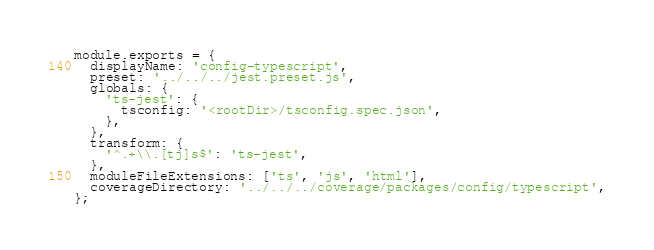<code> <loc_0><loc_0><loc_500><loc_500><_JavaScript_>module.exports = {
  displayName: 'config-typescript',
  preset: '../../../jest.preset.js',
  globals: {
    'ts-jest': {
      tsconfig: '<rootDir>/tsconfig.spec.json',
    },
  },
  transform: {
    '^.+\\.[tj]s$': 'ts-jest',
  },
  moduleFileExtensions: ['ts', 'js', 'html'],
  coverageDirectory: '../../../coverage/packages/config/typescript',
};
</code> 